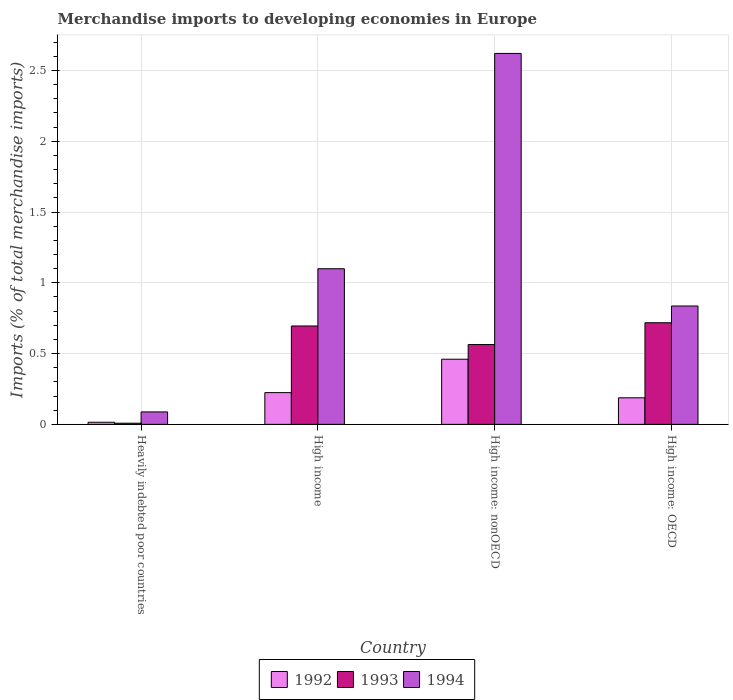How many groups of bars are there?
Provide a succinct answer. 4. Are the number of bars per tick equal to the number of legend labels?
Offer a terse response. Yes. How many bars are there on the 1st tick from the right?
Provide a succinct answer. 3. What is the label of the 3rd group of bars from the left?
Your answer should be compact. High income: nonOECD. What is the percentage total merchandise imports in 1993 in Heavily indebted poor countries?
Offer a terse response. 0.01. Across all countries, what is the maximum percentage total merchandise imports in 1993?
Ensure brevity in your answer.  0.72. Across all countries, what is the minimum percentage total merchandise imports in 1993?
Your answer should be very brief. 0.01. In which country was the percentage total merchandise imports in 1992 maximum?
Provide a succinct answer. High income: nonOECD. In which country was the percentage total merchandise imports in 1992 minimum?
Provide a succinct answer. Heavily indebted poor countries. What is the total percentage total merchandise imports in 1993 in the graph?
Provide a succinct answer. 1.99. What is the difference between the percentage total merchandise imports in 1993 in Heavily indebted poor countries and that in High income: OECD?
Your answer should be very brief. -0.71. What is the difference between the percentage total merchandise imports in 1994 in High income and the percentage total merchandise imports in 1993 in High income: nonOECD?
Your answer should be compact. 0.54. What is the average percentage total merchandise imports in 1994 per country?
Offer a terse response. 1.16. What is the difference between the percentage total merchandise imports of/in 1994 and percentage total merchandise imports of/in 1993 in High income: OECD?
Keep it short and to the point. 0.12. What is the ratio of the percentage total merchandise imports in 1993 in Heavily indebted poor countries to that in High income?
Give a very brief answer. 0.01. Is the percentage total merchandise imports in 1994 in Heavily indebted poor countries less than that in High income?
Provide a short and direct response. Yes. Is the difference between the percentage total merchandise imports in 1994 in High income and High income: nonOECD greater than the difference between the percentage total merchandise imports in 1993 in High income and High income: nonOECD?
Keep it short and to the point. No. What is the difference between the highest and the second highest percentage total merchandise imports in 1994?
Your answer should be very brief. -0.26. What is the difference between the highest and the lowest percentage total merchandise imports in 1994?
Ensure brevity in your answer.  2.53. In how many countries, is the percentage total merchandise imports in 1992 greater than the average percentage total merchandise imports in 1992 taken over all countries?
Ensure brevity in your answer.  2. What does the 1st bar from the left in High income: OECD represents?
Ensure brevity in your answer.  1992. What is the difference between two consecutive major ticks on the Y-axis?
Offer a terse response. 0.5. Are the values on the major ticks of Y-axis written in scientific E-notation?
Make the answer very short. No. Does the graph contain any zero values?
Your answer should be compact. No. Does the graph contain grids?
Your answer should be compact. Yes. Where does the legend appear in the graph?
Give a very brief answer. Bottom center. How many legend labels are there?
Provide a succinct answer. 3. What is the title of the graph?
Offer a terse response. Merchandise imports to developing economies in Europe. What is the label or title of the Y-axis?
Ensure brevity in your answer.  Imports (% of total merchandise imports). What is the Imports (% of total merchandise imports) of 1992 in Heavily indebted poor countries?
Offer a very short reply. 0.02. What is the Imports (% of total merchandise imports) in 1993 in Heavily indebted poor countries?
Offer a terse response. 0.01. What is the Imports (% of total merchandise imports) in 1994 in Heavily indebted poor countries?
Your answer should be very brief. 0.09. What is the Imports (% of total merchandise imports) in 1992 in High income?
Offer a terse response. 0.22. What is the Imports (% of total merchandise imports) of 1993 in High income?
Ensure brevity in your answer.  0.7. What is the Imports (% of total merchandise imports) of 1994 in High income?
Your answer should be compact. 1.1. What is the Imports (% of total merchandise imports) in 1992 in High income: nonOECD?
Provide a succinct answer. 0.46. What is the Imports (% of total merchandise imports) of 1993 in High income: nonOECD?
Offer a very short reply. 0.56. What is the Imports (% of total merchandise imports) in 1994 in High income: nonOECD?
Provide a short and direct response. 2.62. What is the Imports (% of total merchandise imports) in 1992 in High income: OECD?
Provide a succinct answer. 0.19. What is the Imports (% of total merchandise imports) in 1993 in High income: OECD?
Your answer should be compact. 0.72. What is the Imports (% of total merchandise imports) in 1994 in High income: OECD?
Make the answer very short. 0.84. Across all countries, what is the maximum Imports (% of total merchandise imports) of 1992?
Your answer should be compact. 0.46. Across all countries, what is the maximum Imports (% of total merchandise imports) of 1993?
Provide a succinct answer. 0.72. Across all countries, what is the maximum Imports (% of total merchandise imports) of 1994?
Offer a very short reply. 2.62. Across all countries, what is the minimum Imports (% of total merchandise imports) of 1992?
Your answer should be compact. 0.02. Across all countries, what is the minimum Imports (% of total merchandise imports) in 1993?
Provide a succinct answer. 0.01. Across all countries, what is the minimum Imports (% of total merchandise imports) of 1994?
Provide a short and direct response. 0.09. What is the total Imports (% of total merchandise imports) of 1992 in the graph?
Give a very brief answer. 0.89. What is the total Imports (% of total merchandise imports) of 1993 in the graph?
Make the answer very short. 1.99. What is the total Imports (% of total merchandise imports) of 1994 in the graph?
Offer a terse response. 4.64. What is the difference between the Imports (% of total merchandise imports) in 1992 in Heavily indebted poor countries and that in High income?
Your answer should be very brief. -0.21. What is the difference between the Imports (% of total merchandise imports) in 1993 in Heavily indebted poor countries and that in High income?
Provide a succinct answer. -0.69. What is the difference between the Imports (% of total merchandise imports) of 1994 in Heavily indebted poor countries and that in High income?
Your answer should be compact. -1.01. What is the difference between the Imports (% of total merchandise imports) in 1992 in Heavily indebted poor countries and that in High income: nonOECD?
Provide a short and direct response. -0.45. What is the difference between the Imports (% of total merchandise imports) of 1993 in Heavily indebted poor countries and that in High income: nonOECD?
Offer a very short reply. -0.56. What is the difference between the Imports (% of total merchandise imports) of 1994 in Heavily indebted poor countries and that in High income: nonOECD?
Make the answer very short. -2.53. What is the difference between the Imports (% of total merchandise imports) in 1992 in Heavily indebted poor countries and that in High income: OECD?
Your answer should be very brief. -0.17. What is the difference between the Imports (% of total merchandise imports) of 1993 in Heavily indebted poor countries and that in High income: OECD?
Your answer should be very brief. -0.71. What is the difference between the Imports (% of total merchandise imports) in 1994 in Heavily indebted poor countries and that in High income: OECD?
Make the answer very short. -0.75. What is the difference between the Imports (% of total merchandise imports) of 1992 in High income and that in High income: nonOECD?
Your answer should be very brief. -0.24. What is the difference between the Imports (% of total merchandise imports) of 1993 in High income and that in High income: nonOECD?
Make the answer very short. 0.13. What is the difference between the Imports (% of total merchandise imports) in 1994 in High income and that in High income: nonOECD?
Offer a terse response. -1.52. What is the difference between the Imports (% of total merchandise imports) of 1992 in High income and that in High income: OECD?
Your answer should be compact. 0.04. What is the difference between the Imports (% of total merchandise imports) of 1993 in High income and that in High income: OECD?
Make the answer very short. -0.02. What is the difference between the Imports (% of total merchandise imports) of 1994 in High income and that in High income: OECD?
Give a very brief answer. 0.26. What is the difference between the Imports (% of total merchandise imports) of 1992 in High income: nonOECD and that in High income: OECD?
Your answer should be compact. 0.27. What is the difference between the Imports (% of total merchandise imports) in 1993 in High income: nonOECD and that in High income: OECD?
Ensure brevity in your answer.  -0.15. What is the difference between the Imports (% of total merchandise imports) in 1994 in High income: nonOECD and that in High income: OECD?
Your response must be concise. 1.78. What is the difference between the Imports (% of total merchandise imports) of 1992 in Heavily indebted poor countries and the Imports (% of total merchandise imports) of 1993 in High income?
Provide a succinct answer. -0.68. What is the difference between the Imports (% of total merchandise imports) in 1992 in Heavily indebted poor countries and the Imports (% of total merchandise imports) in 1994 in High income?
Provide a succinct answer. -1.08. What is the difference between the Imports (% of total merchandise imports) of 1993 in Heavily indebted poor countries and the Imports (% of total merchandise imports) of 1994 in High income?
Ensure brevity in your answer.  -1.09. What is the difference between the Imports (% of total merchandise imports) of 1992 in Heavily indebted poor countries and the Imports (% of total merchandise imports) of 1993 in High income: nonOECD?
Make the answer very short. -0.55. What is the difference between the Imports (% of total merchandise imports) of 1992 in Heavily indebted poor countries and the Imports (% of total merchandise imports) of 1994 in High income: nonOECD?
Offer a terse response. -2.61. What is the difference between the Imports (% of total merchandise imports) of 1993 in Heavily indebted poor countries and the Imports (% of total merchandise imports) of 1994 in High income: nonOECD?
Offer a terse response. -2.61. What is the difference between the Imports (% of total merchandise imports) of 1992 in Heavily indebted poor countries and the Imports (% of total merchandise imports) of 1993 in High income: OECD?
Give a very brief answer. -0.7. What is the difference between the Imports (% of total merchandise imports) of 1992 in Heavily indebted poor countries and the Imports (% of total merchandise imports) of 1994 in High income: OECD?
Ensure brevity in your answer.  -0.82. What is the difference between the Imports (% of total merchandise imports) in 1993 in Heavily indebted poor countries and the Imports (% of total merchandise imports) in 1994 in High income: OECD?
Keep it short and to the point. -0.83. What is the difference between the Imports (% of total merchandise imports) in 1992 in High income and the Imports (% of total merchandise imports) in 1993 in High income: nonOECD?
Give a very brief answer. -0.34. What is the difference between the Imports (% of total merchandise imports) of 1992 in High income and the Imports (% of total merchandise imports) of 1994 in High income: nonOECD?
Provide a succinct answer. -2.4. What is the difference between the Imports (% of total merchandise imports) of 1993 in High income and the Imports (% of total merchandise imports) of 1994 in High income: nonOECD?
Provide a succinct answer. -1.93. What is the difference between the Imports (% of total merchandise imports) of 1992 in High income and the Imports (% of total merchandise imports) of 1993 in High income: OECD?
Provide a succinct answer. -0.49. What is the difference between the Imports (% of total merchandise imports) in 1992 in High income and the Imports (% of total merchandise imports) in 1994 in High income: OECD?
Offer a very short reply. -0.61. What is the difference between the Imports (% of total merchandise imports) of 1993 in High income and the Imports (% of total merchandise imports) of 1994 in High income: OECD?
Provide a succinct answer. -0.14. What is the difference between the Imports (% of total merchandise imports) in 1992 in High income: nonOECD and the Imports (% of total merchandise imports) in 1993 in High income: OECD?
Your answer should be very brief. -0.26. What is the difference between the Imports (% of total merchandise imports) of 1992 in High income: nonOECD and the Imports (% of total merchandise imports) of 1994 in High income: OECD?
Provide a succinct answer. -0.38. What is the difference between the Imports (% of total merchandise imports) of 1993 in High income: nonOECD and the Imports (% of total merchandise imports) of 1994 in High income: OECD?
Provide a succinct answer. -0.27. What is the average Imports (% of total merchandise imports) of 1992 per country?
Keep it short and to the point. 0.22. What is the average Imports (% of total merchandise imports) in 1993 per country?
Keep it short and to the point. 0.5. What is the average Imports (% of total merchandise imports) of 1994 per country?
Your response must be concise. 1.16. What is the difference between the Imports (% of total merchandise imports) in 1992 and Imports (% of total merchandise imports) in 1993 in Heavily indebted poor countries?
Ensure brevity in your answer.  0.01. What is the difference between the Imports (% of total merchandise imports) in 1992 and Imports (% of total merchandise imports) in 1994 in Heavily indebted poor countries?
Provide a succinct answer. -0.07. What is the difference between the Imports (% of total merchandise imports) of 1993 and Imports (% of total merchandise imports) of 1994 in Heavily indebted poor countries?
Offer a very short reply. -0.08. What is the difference between the Imports (% of total merchandise imports) of 1992 and Imports (% of total merchandise imports) of 1993 in High income?
Your answer should be compact. -0.47. What is the difference between the Imports (% of total merchandise imports) in 1992 and Imports (% of total merchandise imports) in 1994 in High income?
Keep it short and to the point. -0.88. What is the difference between the Imports (% of total merchandise imports) of 1993 and Imports (% of total merchandise imports) of 1994 in High income?
Offer a very short reply. -0.4. What is the difference between the Imports (% of total merchandise imports) of 1992 and Imports (% of total merchandise imports) of 1993 in High income: nonOECD?
Ensure brevity in your answer.  -0.1. What is the difference between the Imports (% of total merchandise imports) in 1992 and Imports (% of total merchandise imports) in 1994 in High income: nonOECD?
Ensure brevity in your answer.  -2.16. What is the difference between the Imports (% of total merchandise imports) in 1993 and Imports (% of total merchandise imports) in 1994 in High income: nonOECD?
Keep it short and to the point. -2.06. What is the difference between the Imports (% of total merchandise imports) of 1992 and Imports (% of total merchandise imports) of 1993 in High income: OECD?
Your response must be concise. -0.53. What is the difference between the Imports (% of total merchandise imports) in 1992 and Imports (% of total merchandise imports) in 1994 in High income: OECD?
Make the answer very short. -0.65. What is the difference between the Imports (% of total merchandise imports) of 1993 and Imports (% of total merchandise imports) of 1994 in High income: OECD?
Keep it short and to the point. -0.12. What is the ratio of the Imports (% of total merchandise imports) in 1992 in Heavily indebted poor countries to that in High income?
Offer a very short reply. 0.07. What is the ratio of the Imports (% of total merchandise imports) in 1993 in Heavily indebted poor countries to that in High income?
Offer a very short reply. 0.01. What is the ratio of the Imports (% of total merchandise imports) in 1994 in Heavily indebted poor countries to that in High income?
Your answer should be very brief. 0.08. What is the ratio of the Imports (% of total merchandise imports) of 1992 in Heavily indebted poor countries to that in High income: nonOECD?
Provide a short and direct response. 0.03. What is the ratio of the Imports (% of total merchandise imports) of 1993 in Heavily indebted poor countries to that in High income: nonOECD?
Offer a terse response. 0.01. What is the ratio of the Imports (% of total merchandise imports) of 1994 in Heavily indebted poor countries to that in High income: nonOECD?
Ensure brevity in your answer.  0.03. What is the ratio of the Imports (% of total merchandise imports) in 1992 in Heavily indebted poor countries to that in High income: OECD?
Provide a short and direct response. 0.08. What is the ratio of the Imports (% of total merchandise imports) of 1993 in Heavily indebted poor countries to that in High income: OECD?
Your answer should be very brief. 0.01. What is the ratio of the Imports (% of total merchandise imports) in 1994 in Heavily indebted poor countries to that in High income: OECD?
Offer a very short reply. 0.11. What is the ratio of the Imports (% of total merchandise imports) of 1992 in High income to that in High income: nonOECD?
Your answer should be compact. 0.49. What is the ratio of the Imports (% of total merchandise imports) of 1993 in High income to that in High income: nonOECD?
Offer a very short reply. 1.23. What is the ratio of the Imports (% of total merchandise imports) of 1994 in High income to that in High income: nonOECD?
Ensure brevity in your answer.  0.42. What is the ratio of the Imports (% of total merchandise imports) in 1992 in High income to that in High income: OECD?
Your response must be concise. 1.19. What is the ratio of the Imports (% of total merchandise imports) in 1993 in High income to that in High income: OECD?
Provide a succinct answer. 0.97. What is the ratio of the Imports (% of total merchandise imports) in 1994 in High income to that in High income: OECD?
Your answer should be very brief. 1.31. What is the ratio of the Imports (% of total merchandise imports) of 1992 in High income: nonOECD to that in High income: OECD?
Your answer should be very brief. 2.45. What is the ratio of the Imports (% of total merchandise imports) in 1993 in High income: nonOECD to that in High income: OECD?
Provide a short and direct response. 0.79. What is the ratio of the Imports (% of total merchandise imports) of 1994 in High income: nonOECD to that in High income: OECD?
Offer a very short reply. 3.13. What is the difference between the highest and the second highest Imports (% of total merchandise imports) of 1992?
Provide a succinct answer. 0.24. What is the difference between the highest and the second highest Imports (% of total merchandise imports) in 1993?
Provide a short and direct response. 0.02. What is the difference between the highest and the second highest Imports (% of total merchandise imports) in 1994?
Provide a short and direct response. 1.52. What is the difference between the highest and the lowest Imports (% of total merchandise imports) in 1992?
Provide a short and direct response. 0.45. What is the difference between the highest and the lowest Imports (% of total merchandise imports) of 1993?
Ensure brevity in your answer.  0.71. What is the difference between the highest and the lowest Imports (% of total merchandise imports) of 1994?
Provide a succinct answer. 2.53. 